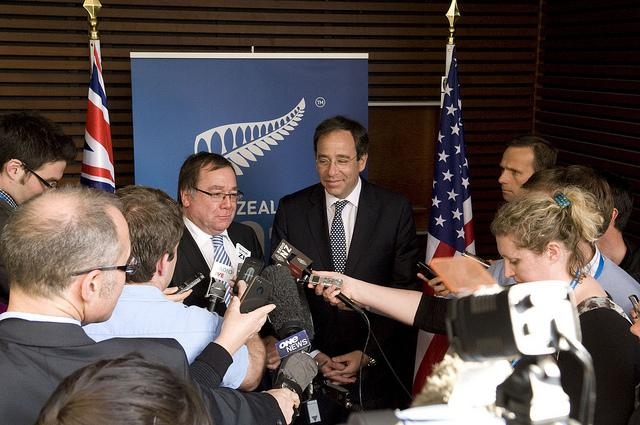What does the NZ on the microphone stand for? new zealand 